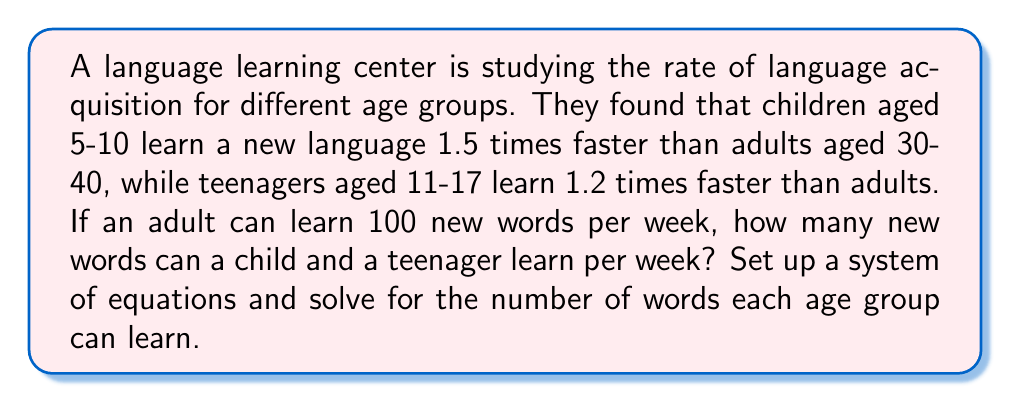Help me with this question. Let's approach this step-by-step:

1) Let's define our variables:
   $x$ = number of words a child (5-10) can learn per week
   $y$ = number of words a teenager (11-17) can learn per week
   We know that an adult (30-40) can learn 100 words per week

2) Now, we can set up our system of equations based on the given information:

   Equation 1: $x = 1.5 * 100$ (children learn 1.5 times faster than adults)
   Equation 2: $y = 1.2 * 100$ (teenagers learn 1.2 times faster than adults)

3) Let's solve these equations:

   From Equation 1:
   $x = 1.5 * 100 = 150$

   From Equation 2:
   $y = 1.2 * 100 = 120$

4) Therefore, children aged 5-10 can learn 150 words per week, and teenagers aged 11-17 can learn 120 words per week.

This system of equations is simple and can be solved by direct calculation. In more complex scenarios, we might need to use substitution or elimination methods to solve the system.
Answer: Children (5-10): 150 words per week
Teenagers (11-17): 120 words per week 